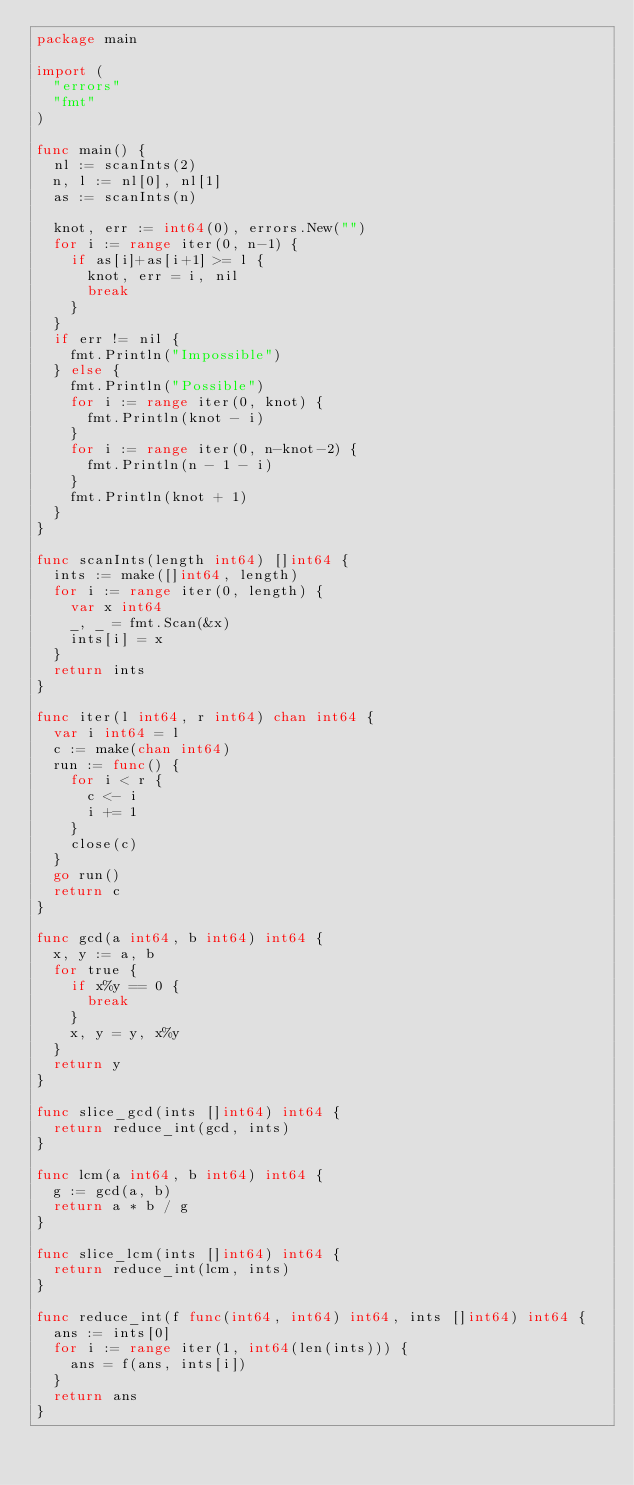<code> <loc_0><loc_0><loc_500><loc_500><_Go_>package main

import (
	"errors"
	"fmt"
)

func main() {
	nl := scanInts(2)
	n, l := nl[0], nl[1]
	as := scanInts(n)

	knot, err := int64(0), errors.New("")
	for i := range iter(0, n-1) {
		if as[i]+as[i+1] >= l {
			knot, err = i, nil
			break
		}
	}
	if err != nil {
		fmt.Println("Impossible")
	} else {
		fmt.Println("Possible")
		for i := range iter(0, knot) {
			fmt.Println(knot - i)
		}
		for i := range iter(0, n-knot-2) {
			fmt.Println(n - 1 - i)
		}
		fmt.Println(knot + 1)
	}
}

func scanInts(length int64) []int64 {
	ints := make([]int64, length)
	for i := range iter(0, length) {
		var x int64
		_, _ = fmt.Scan(&x)
		ints[i] = x
	}
	return ints
}

func iter(l int64, r int64) chan int64 {
	var i int64 = l
	c := make(chan int64)
	run := func() {
		for i < r {
			c <- i
			i += 1
		}
		close(c)
	}
	go run()
	return c
}

func gcd(a int64, b int64) int64 {
	x, y := a, b
	for true {
		if x%y == 0 {
			break
		}
		x, y = y, x%y
	}
	return y
}

func slice_gcd(ints []int64) int64 {
	return reduce_int(gcd, ints)
}

func lcm(a int64, b int64) int64 {
	g := gcd(a, b)
	return a * b / g
}

func slice_lcm(ints []int64) int64 {
	return reduce_int(lcm, ints)
}

func reduce_int(f func(int64, int64) int64, ints []int64) int64 {
	ans := ints[0]
	for i := range iter(1, int64(len(ints))) {
		ans = f(ans, ints[i])
	}
	return ans
}
</code> 